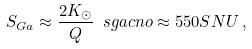<formula> <loc_0><loc_0><loc_500><loc_500>S _ { G a } \approx \frac { 2 K _ { \odot } } { Q } \ s g a c n o \approx 5 5 0 S N U \, ,</formula> 